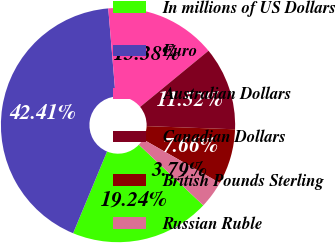Convert chart to OTSL. <chart><loc_0><loc_0><loc_500><loc_500><pie_chart><fcel>In millions of US Dollars<fcel>Euro<fcel>Australian Dollars<fcel>Canadian Dollars<fcel>British Pounds Sterling<fcel>Russian Ruble<nl><fcel>19.24%<fcel>42.41%<fcel>15.38%<fcel>11.52%<fcel>7.66%<fcel>3.79%<nl></chart> 